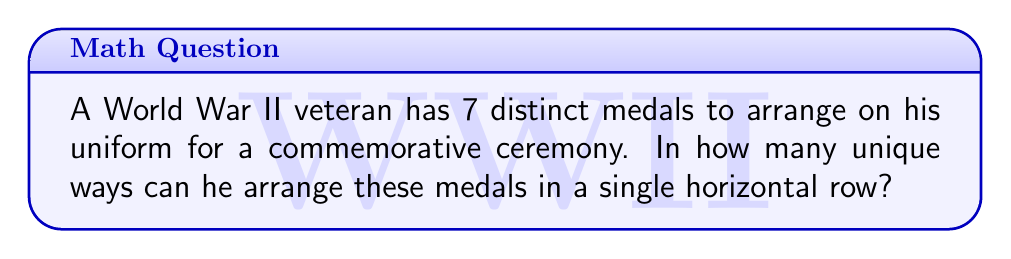Can you solve this math problem? Let's approach this step-by-step:

1) This problem is a straightforward application of permutations. We need to arrange 7 distinct objects (medals) in a specific order.

2) In permutation problems, when we have n distinct objects and we want to arrange all of them, the number of possible arrangements is given by n!.

3) In this case, we have 7 distinct medals. Therefore, n = 7.

4) The formula for the number of permutations is:

   $$ P = n! $$

5) Substituting n = 7:

   $$ P = 7! $$

6) Let's calculate this:
   
   $$ 7! = 7 \times 6 \times 5 \times 4 \times 3 \times 2 \times 1 = 5040 $$

Therefore, there are 5040 unique ways to arrange the 7 medals on the uniform.
Answer: 5040 